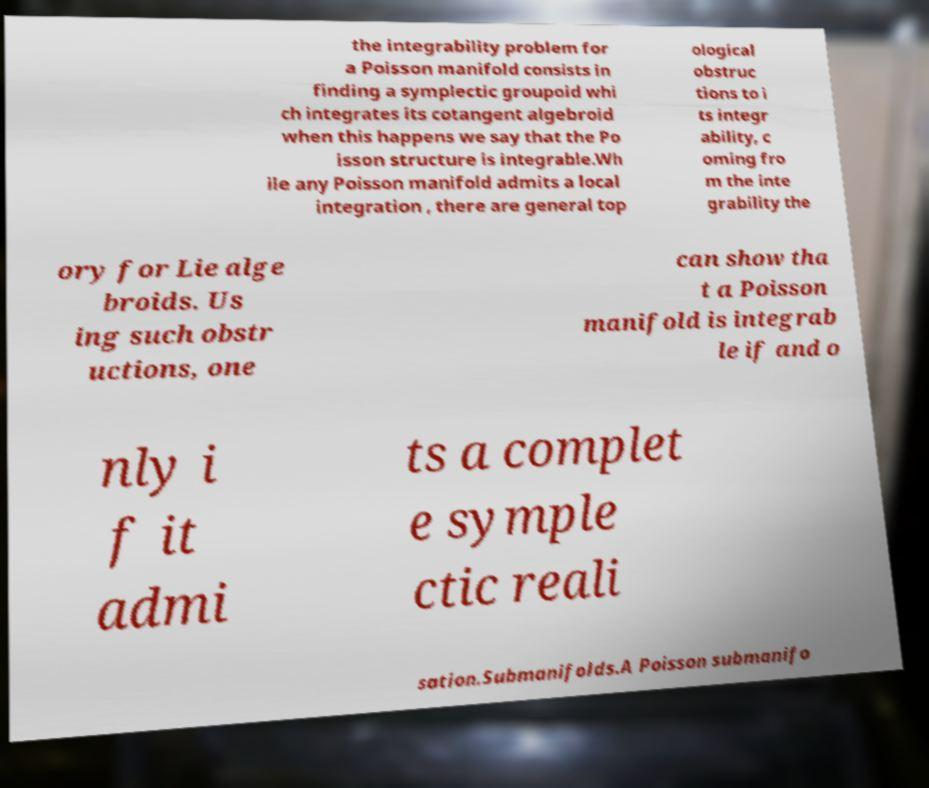Please identify and transcribe the text found in this image. the integrability problem for a Poisson manifold consists in finding a symplectic groupoid whi ch integrates its cotangent algebroid when this happens we say that the Po isson structure is integrable.Wh ile any Poisson manifold admits a local integration , there are general top ological obstruc tions to i ts integr ability, c oming fro m the inte grability the ory for Lie alge broids. Us ing such obstr uctions, one can show tha t a Poisson manifold is integrab le if and o nly i f it admi ts a complet e symple ctic reali sation.Submanifolds.A Poisson submanifo 